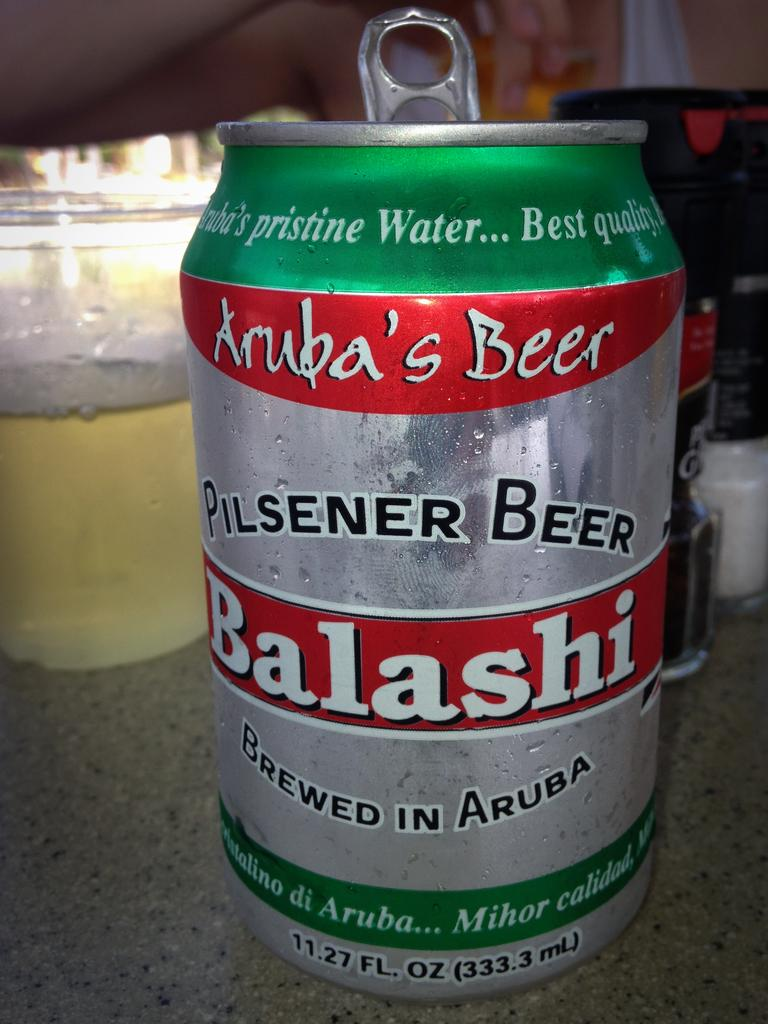<image>
Offer a succinct explanation of the picture presented. a beer can with Balashi on the surface 